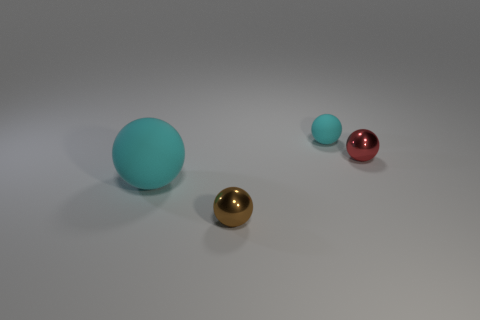The tiny object that is in front of the tiny cyan object and right of the brown metallic ball is what color?
Offer a terse response. Red. Are there fewer metal spheres behind the large cyan matte thing than small brown objects to the left of the brown sphere?
Provide a succinct answer. No. What number of brown metal things are the same shape as the small red object?
Give a very brief answer. 1. What is the size of the other sphere that is the same material as the tiny cyan sphere?
Provide a short and direct response. Large. What is the color of the ball that is behind the small shiny sphere that is to the right of the tiny matte object?
Offer a very short reply. Cyan. Is the shape of the brown metal thing the same as the rubber thing that is in front of the tiny red ball?
Give a very brief answer. Yes. How many cyan objects have the same size as the brown thing?
Keep it short and to the point. 1. There is a tiny red object that is the same shape as the small brown object; what is its material?
Offer a very short reply. Metal. Is the color of the small shiny ball that is in front of the large thing the same as the shiny thing behind the big cyan ball?
Your answer should be very brief. No. There is a cyan matte object to the right of the brown metallic ball; what shape is it?
Offer a very short reply. Sphere. 